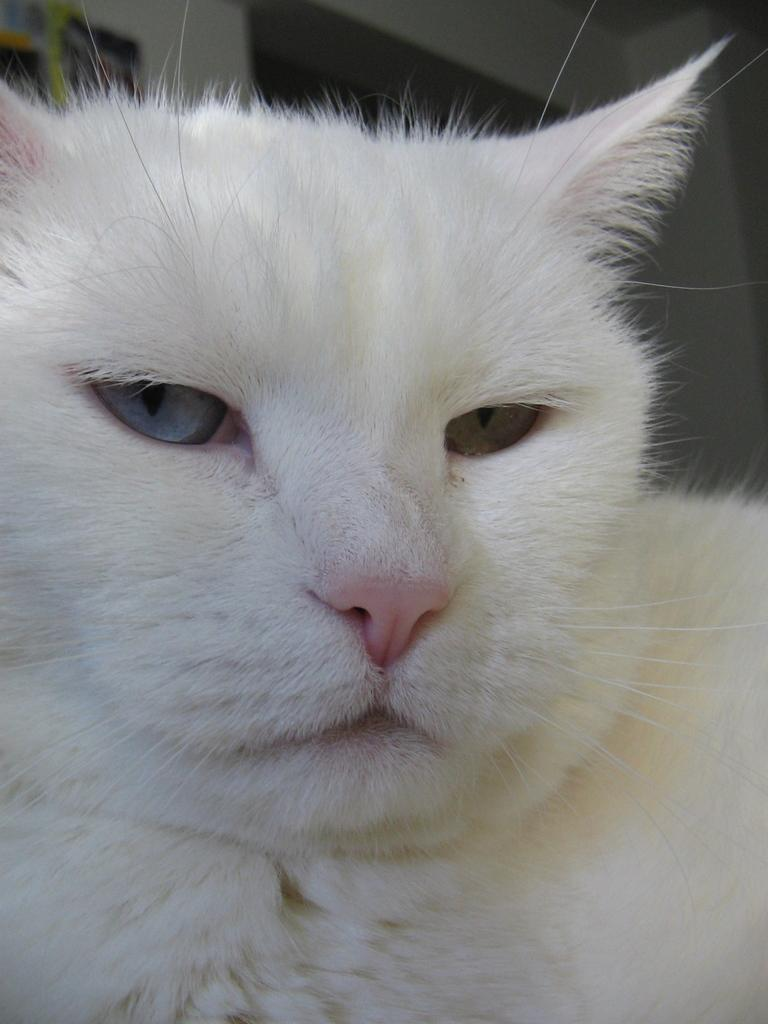What type of animal can be seen in the picture? There is a white cat in the picture. What is visible in the background of the picture? There is a door visible in the background of the picture. Where are the photo frames located in the image? The photo frames are on the wall in the top left corner of the image. What type of spark can be seen coming from the cat's eyes in the image? There is no spark visible in the image, and the cat's eyes do not emit any light or energy. 